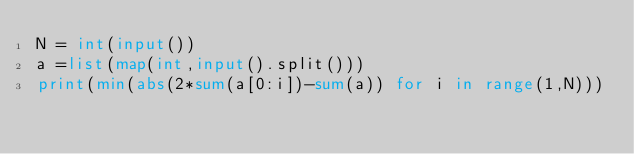Convert code to text. <code><loc_0><loc_0><loc_500><loc_500><_Python_>N = int(input())
a =list(map(int,input().split()))
print(min(abs(2*sum(a[0:i])-sum(a)) for i in range(1,N)))</code> 